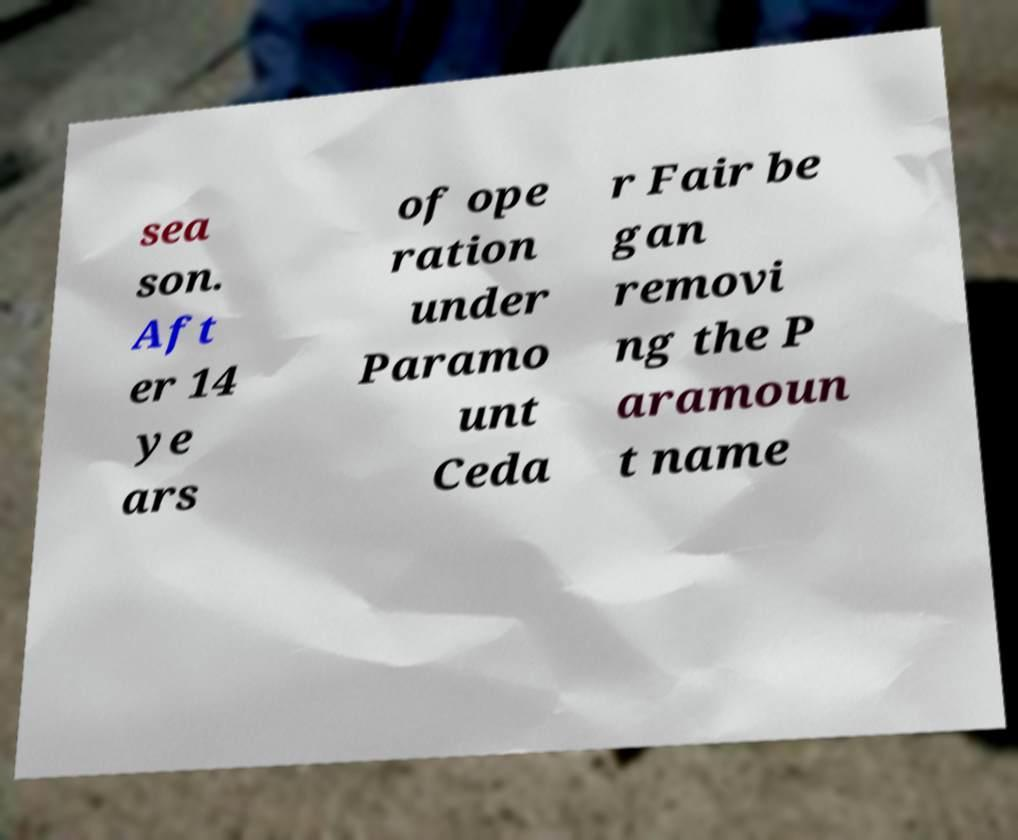For documentation purposes, I need the text within this image transcribed. Could you provide that? sea son. Aft er 14 ye ars of ope ration under Paramo unt Ceda r Fair be gan removi ng the P aramoun t name 